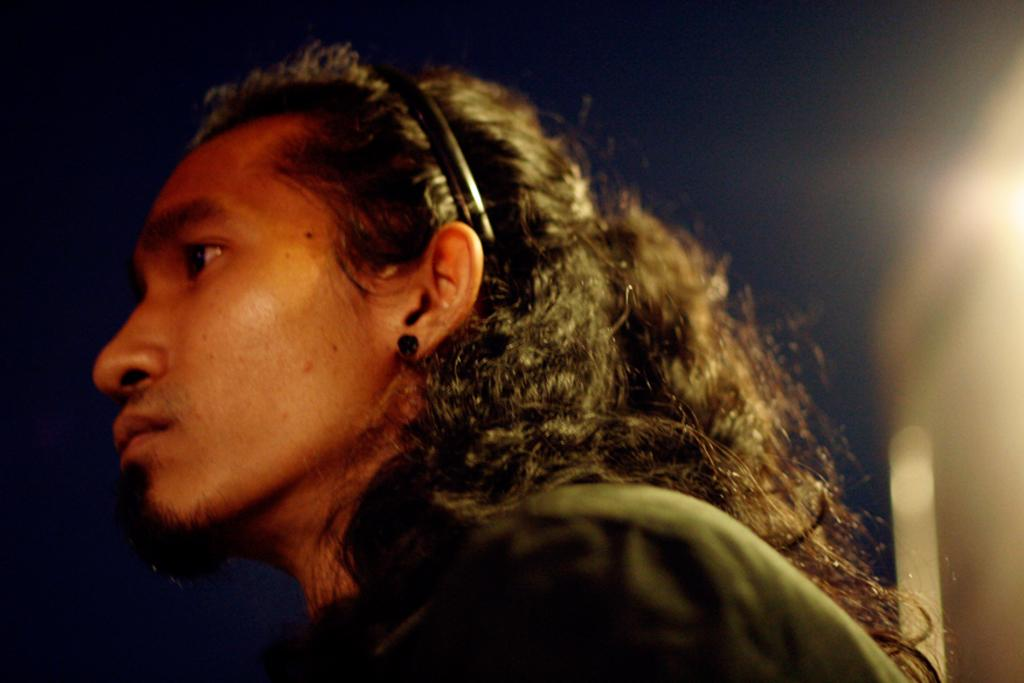What is the main subject in the foreground of the image? There is a person with long hair in the foreground of the image. What can be seen in the background of the image? There is sky visible in the background of the image. What type of quilt is being used to cover the person in the image? There is no quilt present in the image; it only features a person with long hair and sky in the background. 